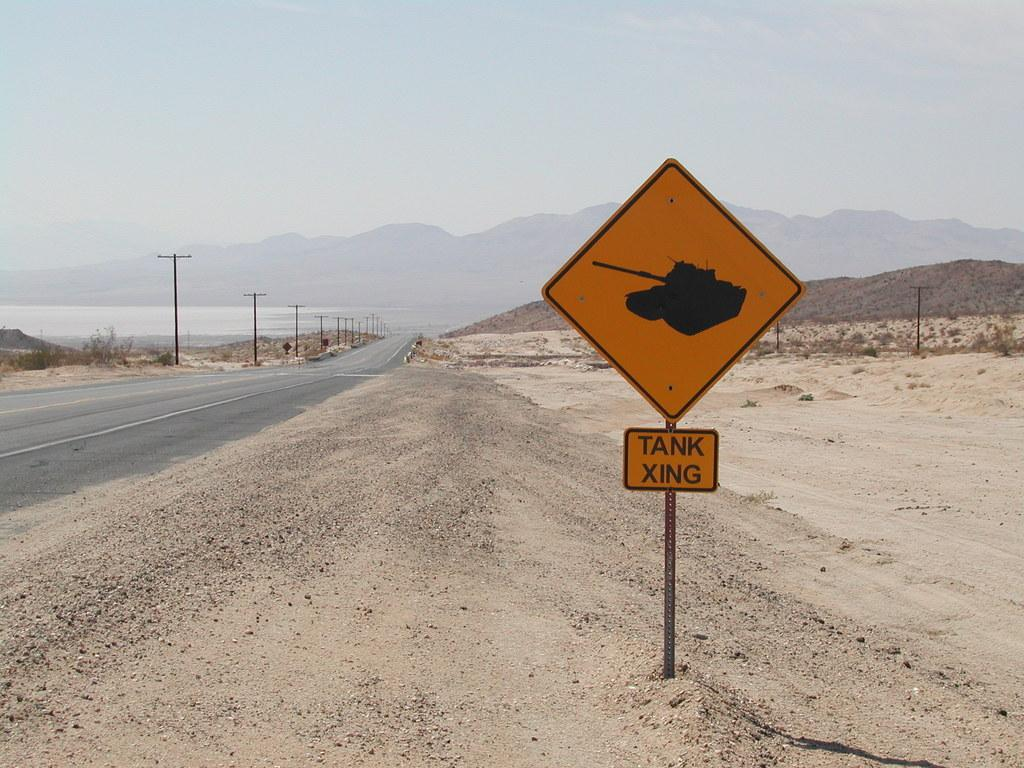Provide a one-sentence caption for the provided image. A yellow sign on the side of a desert road that indicates a tank crossing. 